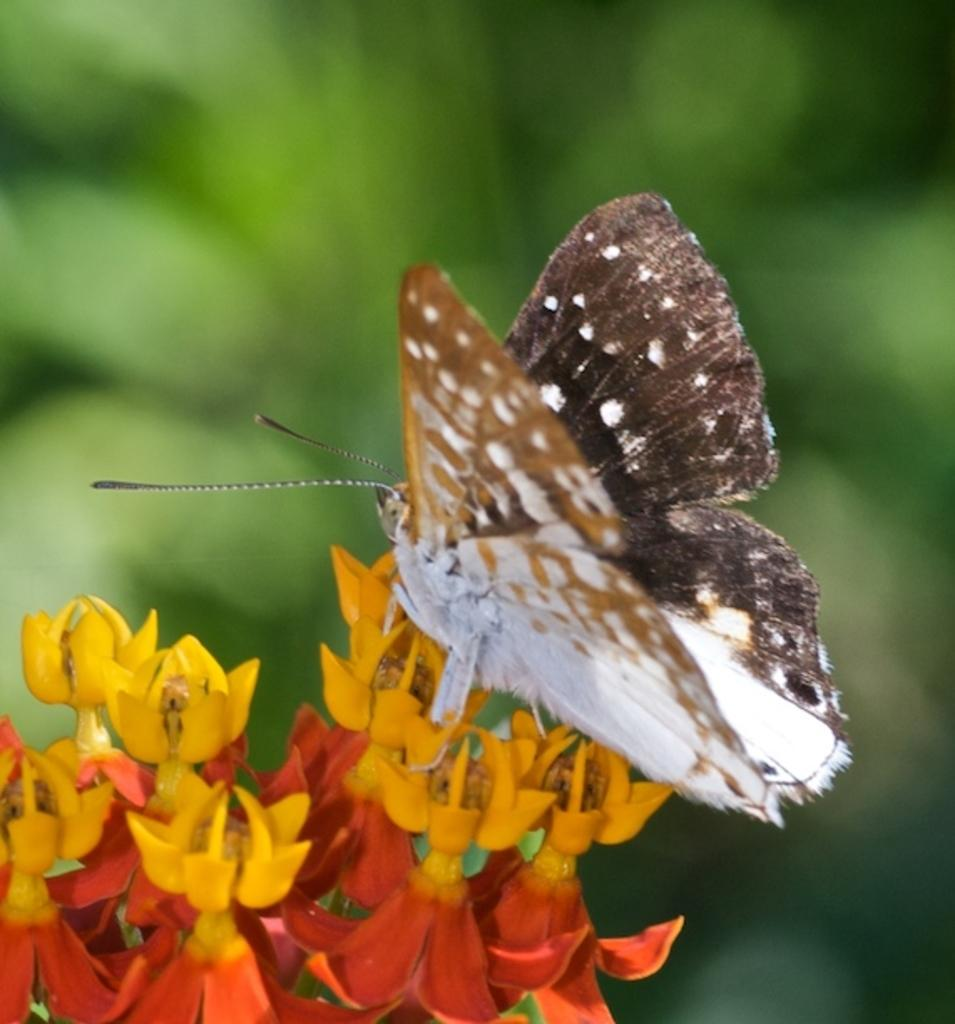What is the main subject of the image? There is a butterfly in the image. Where is the butterfly located in the image? The butterfly is sitting on a flower. Can you describe the flower that the butterfly is on? There is a flower at the bottom of the image. What can be seen in the background of the image? There are green plants visible in the background of the image. How many lizards are crawling on the butterfly's throat in the image? There are no lizards present in the image, and butterflies do not have throats. What type of ring can be seen on the butterfly's leg in the image? There is no ring visible on the butterfly's leg in the image, as butterflies do not wear rings. 